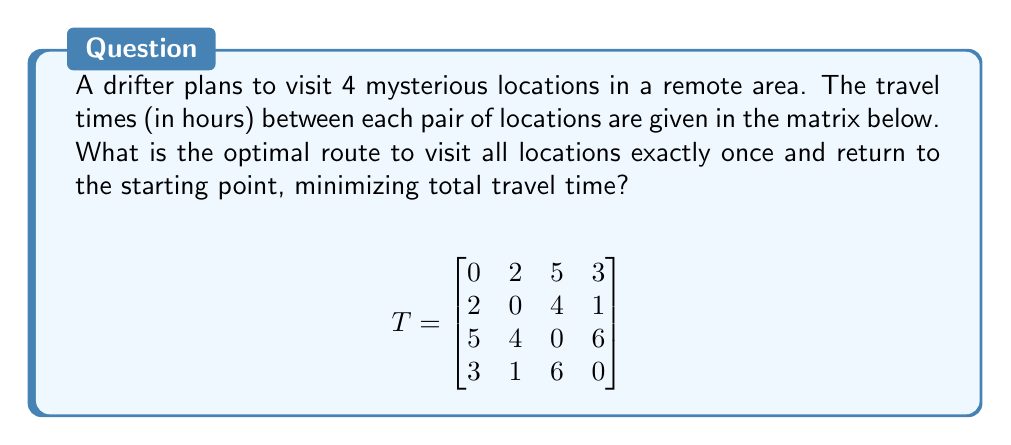Help me with this question. To solve this problem, we'll use the following steps:

1) Recognize this as a Traveling Salesman Problem (TSP).

2) With 4 locations, there are $(4-1)! = 6$ possible routes (starting and ending at the same location).

3) Calculate the total travel time for each route:

   Route 1-2-3-4-1: $T_{12} + T_{23} + T_{34} + T_{41} = 2 + 4 + 6 + 3 = 15$
   Route 1-2-4-3-1: $T_{12} + T_{24} + T_{43} + T_{31} = 2 + 1 + 6 + 5 = 14$
   Route 1-3-2-4-1: $T_{13} + T_{32} + T_{24} + T_{41} = 5 + 4 + 1 + 3 = 13$
   Route 1-3-4-2-1: $T_{13} + T_{34} + T_{42} + T_{21} = 5 + 6 + 1 + 2 = 14$
   Route 1-4-2-3-1: $T_{14} + T_{42} + T_{23} + T_{31} = 3 + 1 + 4 + 5 = 13$
   Route 1-4-3-2-1: $T_{14} + T_{43} + T_{32} + T_{21} = 3 + 6 + 4 + 2 = 15$

4) The minimum travel time is 13 hours, achieved by two routes: 1-3-2-4-1 and 1-4-2-3-1.

5) Both are optimal solutions, but we'll choose 1-3-2-4-1 as our answer.
Answer: 1-3-2-4-1 